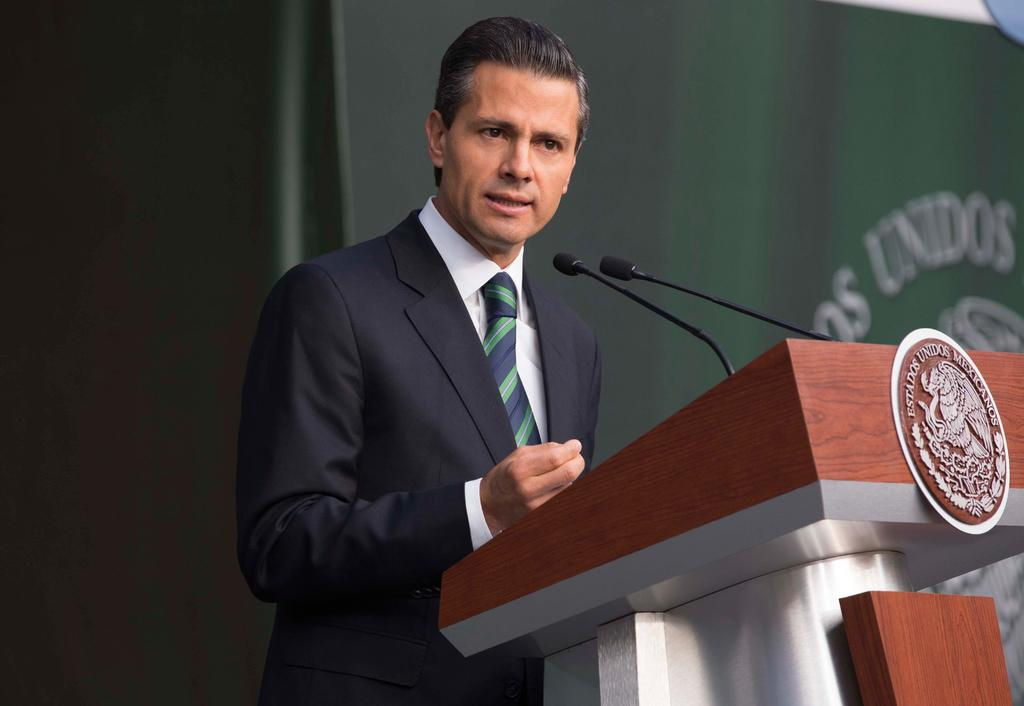What is the main subject of the image? There is a person in the image. What is the person wearing? The person is wearing a black suit. What is the person doing in the image? The person is talking. What is in front of the person? There is a podium in front of the person. How many microphones are on the podium? There are two microphones on the podium. Can you describe the background of the image? The background of the image is blurred. What type of gun is the person holding in the image? There is no gun present in the image; the person is wearing a black suit and talking at a podium with two microphones. What type of root can be seen growing near the podium in the image? There are no roots visible in the image; the background is blurred, and the focus is on the person, podium, and microphones. 